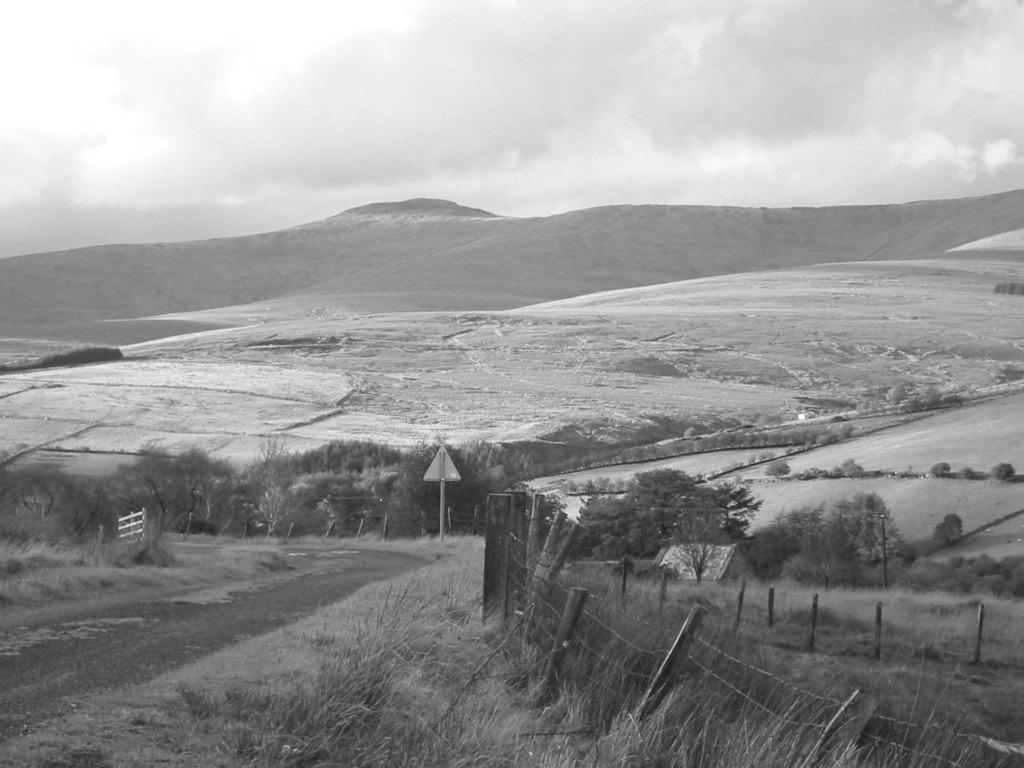Can you describe this image briefly? It is a black and white image. In this image at front there is a grass on the surface and at the background there are trees, mountains and sky. 